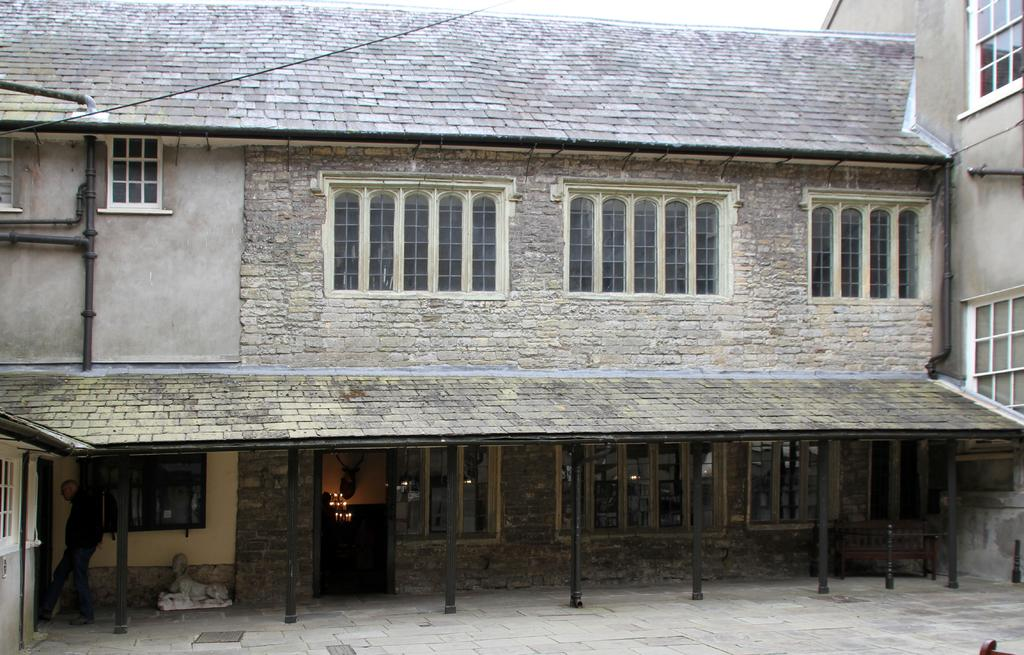What type of structure is in the picture? There is a building in the picture. What feature can be observed on the building? The building has glass windows. How would you describe the sky in the picture? The sky is cloudy in the picture. What type of skin condition is visible on the building in the image? There is no skin condition present on the building; it is a structure made of materials like glass and other construction materials. 